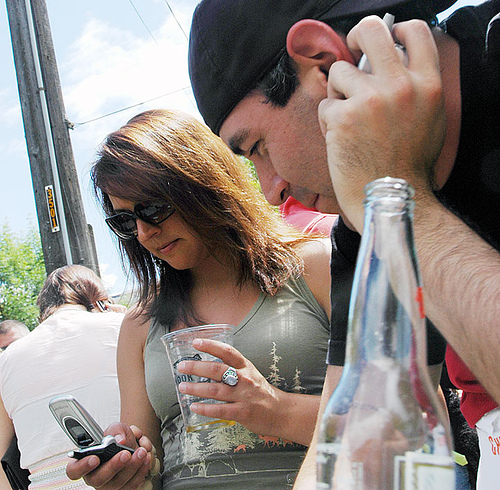Please identify all text content in this image. 3 5 0 look 